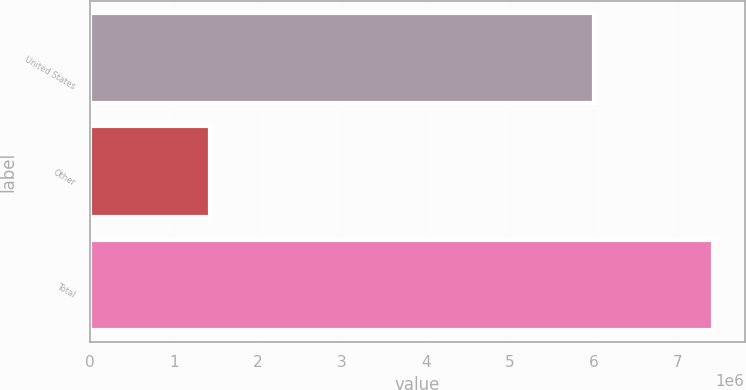Convert chart to OTSL. <chart><loc_0><loc_0><loc_500><loc_500><bar_chart><fcel>United States<fcel>Other<fcel>Total<nl><fcel>5.99656e+06<fcel>1.4252e+06<fcel>7.42177e+06<nl></chart> 